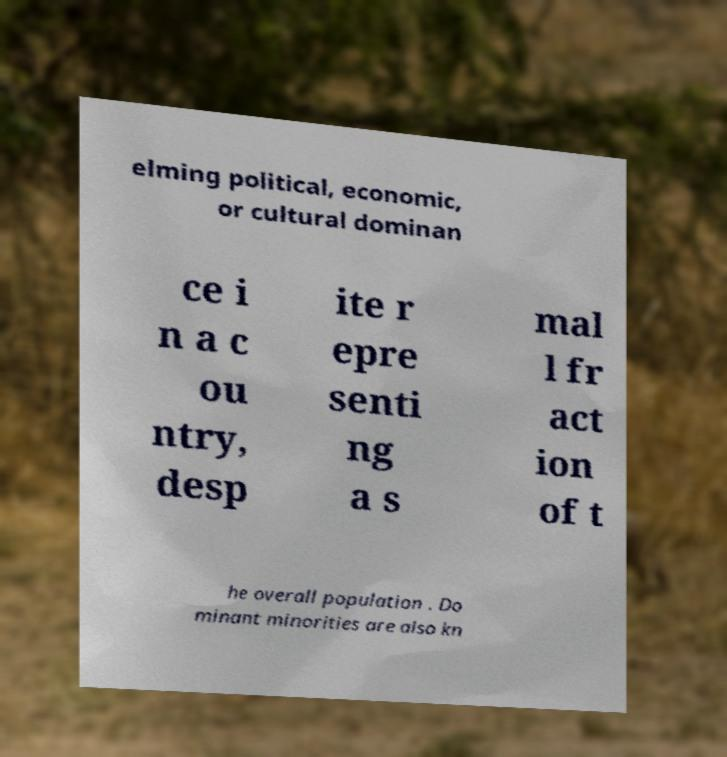Could you assist in decoding the text presented in this image and type it out clearly? elming political, economic, or cultural dominan ce i n a c ou ntry, desp ite r epre senti ng a s mal l fr act ion of t he overall population . Do minant minorities are also kn 